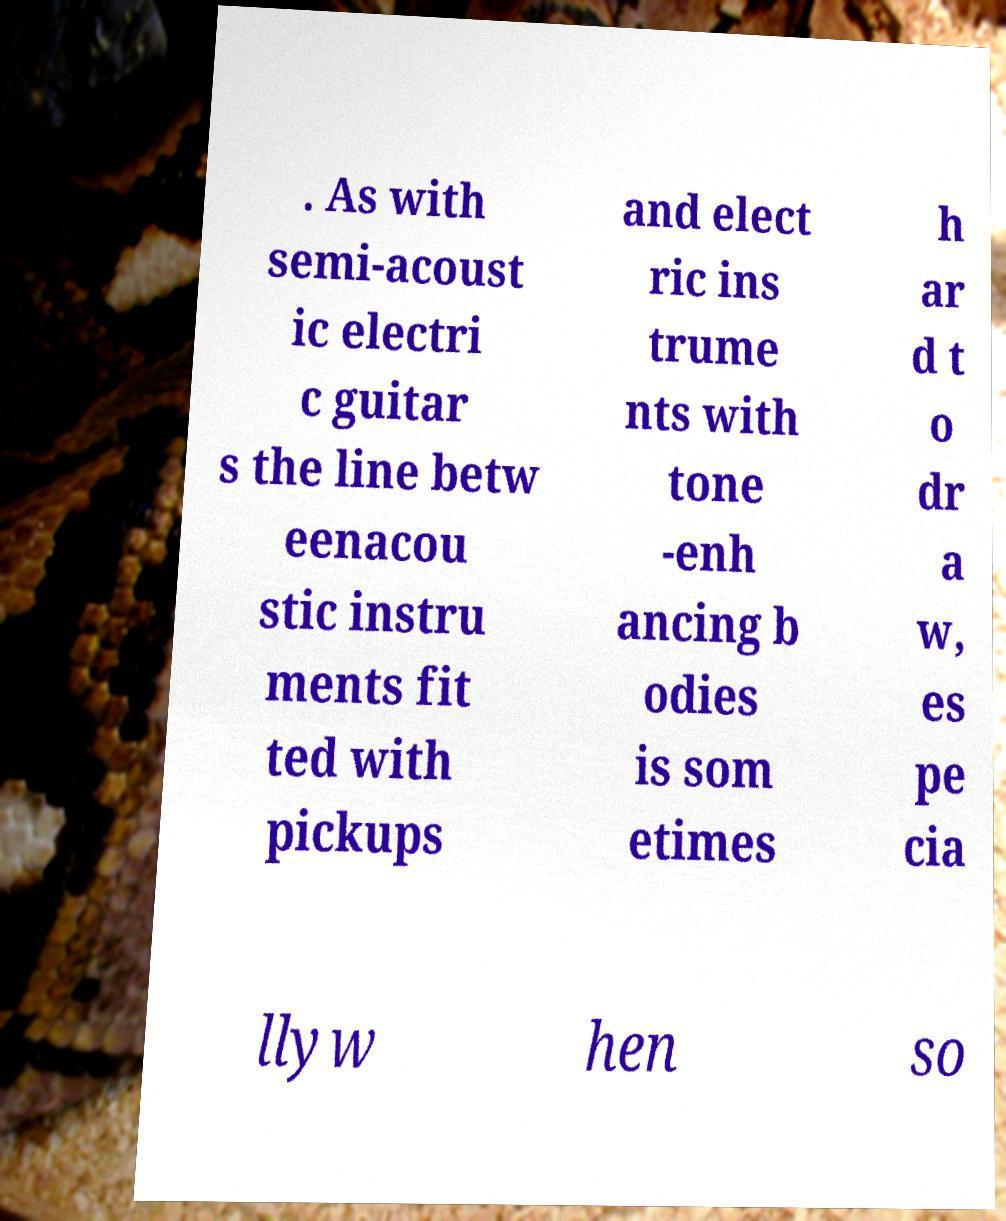There's text embedded in this image that I need extracted. Can you transcribe it verbatim? . As with semi-acoust ic electri c guitar s the line betw eenacou stic instru ments fit ted with pickups and elect ric ins trume nts with tone -enh ancing b odies is som etimes h ar d t o dr a w, es pe cia llyw hen so 